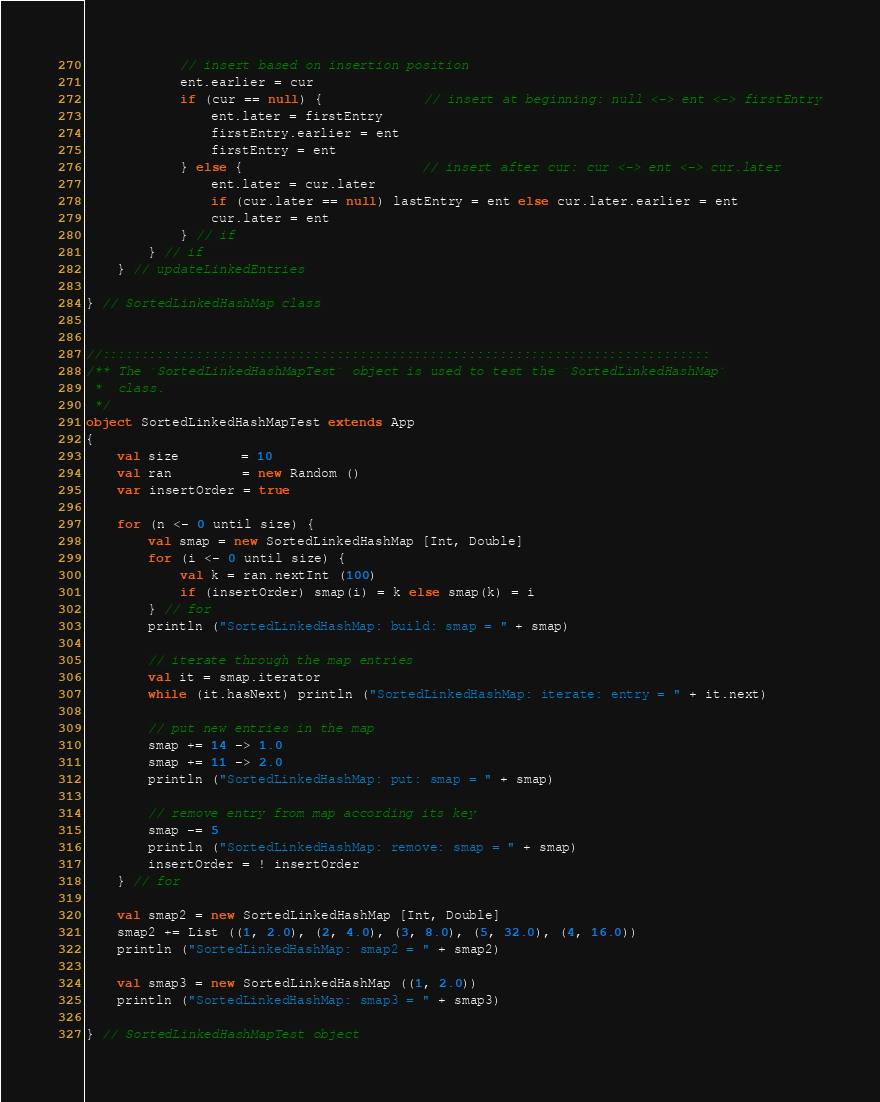<code> <loc_0><loc_0><loc_500><loc_500><_Scala_>
            // insert based on insertion position
            ent.earlier = cur
            if (cur == null) {             // insert at beginning: null <-> ent <-> firstEntry
                ent.later = firstEntry
                firstEntry.earlier = ent
                firstEntry = ent
            } else {                       // insert after cur: cur <-> ent <-> cur.later
                ent.later = cur.later
                if (cur.later == null) lastEntry = ent else cur.later.earlier = ent
                cur.later = ent
            } // if
        } // if
    } // updateLinkedEntries

} // SortedLinkedHashMap class


//::::::::::::::::::::::::::::::::::::::::::::::::::::::::::::::::::::::::::::::
/** The `SortedLinkedHashMapTest` object is used to test the `SortedLinkedHashMap`
 *  class.
 */
object SortedLinkedHashMapTest extends App
{
    val size        = 10
    val ran         = new Random ()
    var insertOrder = true

    for (n <- 0 until size) {
        val smap = new SortedLinkedHashMap [Int, Double]
        for (i <- 0 until size) {
            val k = ran.nextInt (100)
            if (insertOrder) smap(i) = k else smap(k) = i
        } // for
        println ("SortedLinkedHashMap: build: smap = " + smap)

        // iterate through the map entries
        val it = smap.iterator
        while (it.hasNext) println ("SortedLinkedHashMap: iterate: entry = " + it.next) 
        
        // put new entries in the map
        smap += 14 -> 1.0
        smap += 11 -> 2.0
        println ("SortedLinkedHashMap: put: smap = " + smap)
        
        // remove entry from map according its key
        smap -= 5 
        println ("SortedLinkedHashMap: remove: smap = " + smap)
        insertOrder = ! insertOrder
    } // for

    val smap2 = new SortedLinkedHashMap [Int, Double]
    smap2 += List ((1, 2.0), (2, 4.0), (3, 8.0), (5, 32.0), (4, 16.0))
    println ("SortedLinkedHashMap: smap2 = " + smap2)

    val smap3 = new SortedLinkedHashMap ((1, 2.0))
    println ("SortedLinkedHashMap: smap3 = " + smap3)

} // SortedLinkedHashMapTest object

</code> 